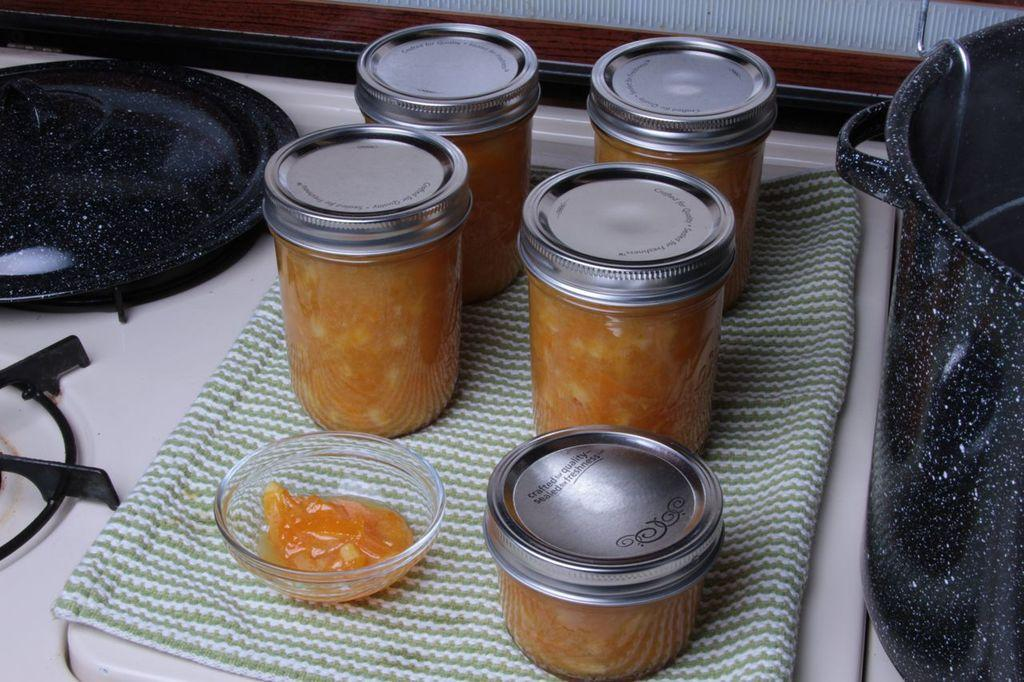What type of containers are present in the image? There are jars with lids in the image. What else can be seen in the image besides the jars? There is a bowl, a napkin, a pan, and a stove in the image. Where is the bowl located in the image? There is a bowl on a white surface in the image. What is the purpose of the stove in the image? The stove is likely used for cooking or heating food. Can you describe the brain of the man in the image? There is no man present in the image, and therefore no brain to describe. How tall are the giants in the image? There are no giants present in the image. 